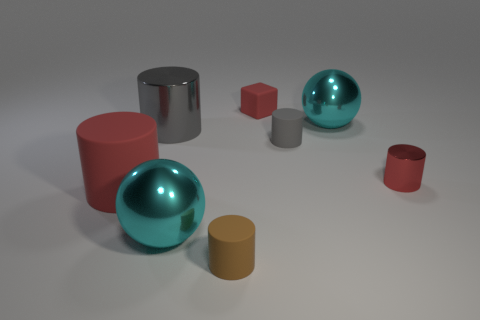Subtract all brown cylinders. How many cylinders are left? 4 Subtract all gray cylinders. How many cylinders are left? 3 Subtract 1 cylinders. How many cylinders are left? 4 Add 1 small shiny cylinders. How many objects exist? 9 Subtract all blocks. How many objects are left? 7 Add 7 large cyan spheres. How many large cyan spheres exist? 9 Subtract 0 green cubes. How many objects are left? 8 Subtract all yellow balls. Subtract all red cylinders. How many balls are left? 2 Subtract all blue cubes. How many gray cylinders are left? 2 Subtract all tiny red rubber blocks. Subtract all small brown matte things. How many objects are left? 6 